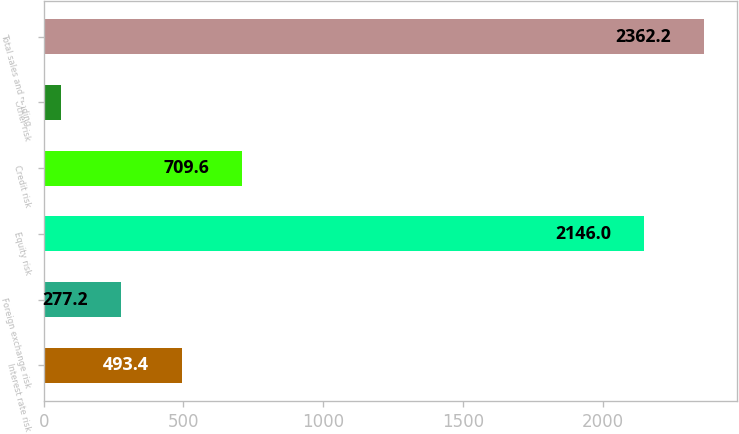Convert chart. <chart><loc_0><loc_0><loc_500><loc_500><bar_chart><fcel>Interest rate risk<fcel>Foreign exchange risk<fcel>Equity risk<fcel>Credit risk<fcel>Other risk<fcel>Total sales and trading<nl><fcel>493.4<fcel>277.2<fcel>2146<fcel>709.6<fcel>61<fcel>2362.2<nl></chart> 